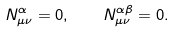<formula> <loc_0><loc_0><loc_500><loc_500>N _ { \mu \nu } ^ { \alpha } = 0 , \quad N _ { \mu \nu } ^ { \alpha \beta } = 0 .</formula> 